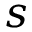Convert formula to latex. <formula><loc_0><loc_0><loc_500><loc_500>s</formula> 